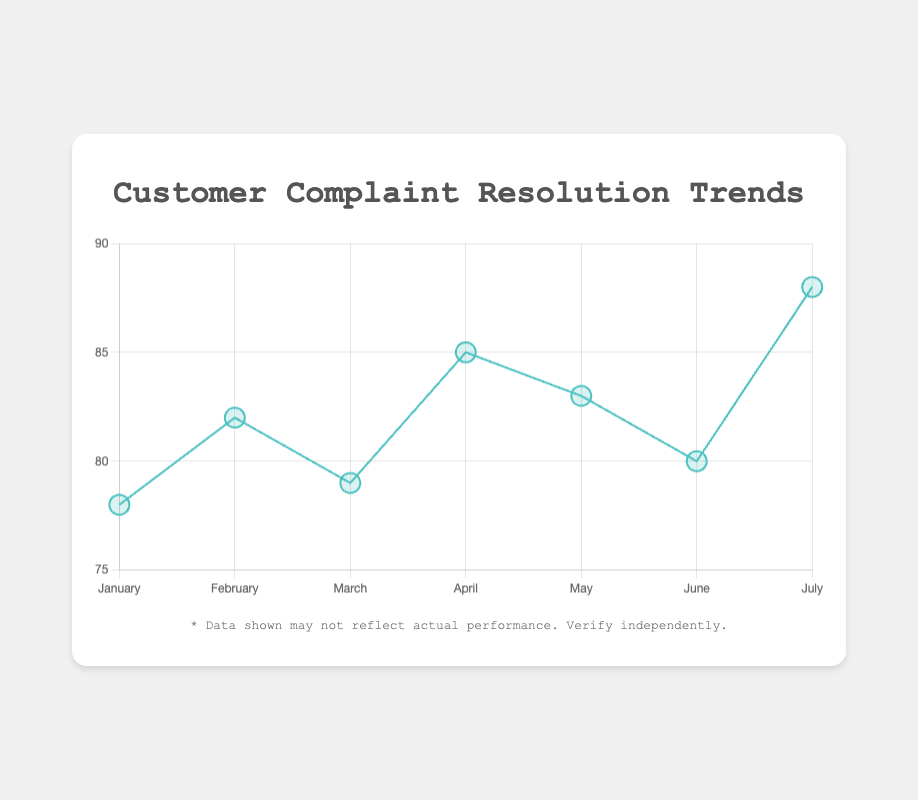What is the percentage of resolved complaints in April? The point for April on the chart shows a resolved complaint percentage. By looking at the point's vertical position, we can see that it corresponds to 85%.
Answer: 85% What is the trend in the complaint resolution percentage from January to July? Analyzing the line graph from left to right reveals an overall upward trajectory, with some fluctuations. Starting at 78% in January and reaching 88% in July, the trend shows improvement.
Answer: Upward trend with fluctuations Which month had the highest resolution percentage of complaints? By examining the peaks of the graph, the highest point is in July, where the resolution percentage is 88%.
Answer: July Compare the complaint resolution percentages of February and June. Which month had a higher percentage and by how much? February has an 82% resolution rate and June has 80%. The difference is 82% - 80% = 2%.
Answer: February by 2% What emoji corresponds to March, and what does it indicate about the resolution percentage? The emoji for March is 😐, which indicates a mediocre resolution percentage close to the lower threshold of the monthly range (above 75% but below 85%). Specifically, March has 79%.
Answer: 😐 Calculate the average resolution percentage from January to July. Add up the resolution percentages: (78 + 82 + 79 + 85 + 83 + 80 + 88), then divide by the number of months (7): (575 / 7) ≈ 82.14%.
Answer: 82.14% What is the difference between the lowest and highest resolution percentages over this period? The lowest resolution percentage is 78% (January) and the highest is 88% (July). The difference is 88% - 78% = 10%.
Answer: 10% Which months have a resolution percentage above the overall average? With the average at 82.14%, we need months above this threshold. February (82%), April (85%), May (83%), and July (88%) are above the average.
Answer: February, April, May, July How many months had a "🙂" emoji and what were the corresponding resolution percentages? By identifying the months with the "🙂" emoji on the chart: February and May represent this emoji. Their percentages are 82% and 83%, respectively.
Answer: 2 months: 82% and 83% 